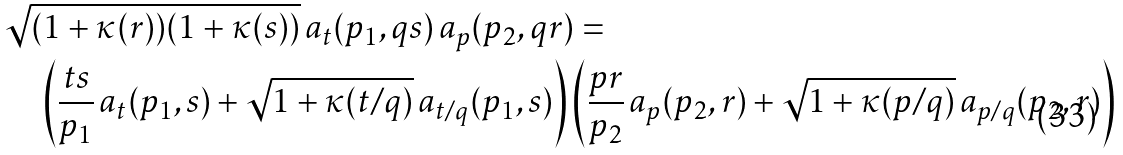<formula> <loc_0><loc_0><loc_500><loc_500>& \sqrt { ( 1 + \kappa ( r ) ) ( 1 + \kappa ( s ) ) } \, a _ { t } ( p _ { 1 } , q s ) \, a _ { p } ( p _ { 2 } , q r ) = \\ & \quad \left ( \frac { t s } { p _ { 1 } } \, a _ { t } ( p _ { 1 } , s ) + \sqrt { 1 + \kappa ( t / q ) } \, a _ { t / q } ( p _ { 1 } , s ) \right ) \left ( \frac { p r } { p _ { 2 } } \, a _ { p } ( p _ { 2 } , r ) + \sqrt { 1 + \kappa ( p / q ) } \, a _ { p / q } ( p _ { 2 } , r ) \right )</formula> 